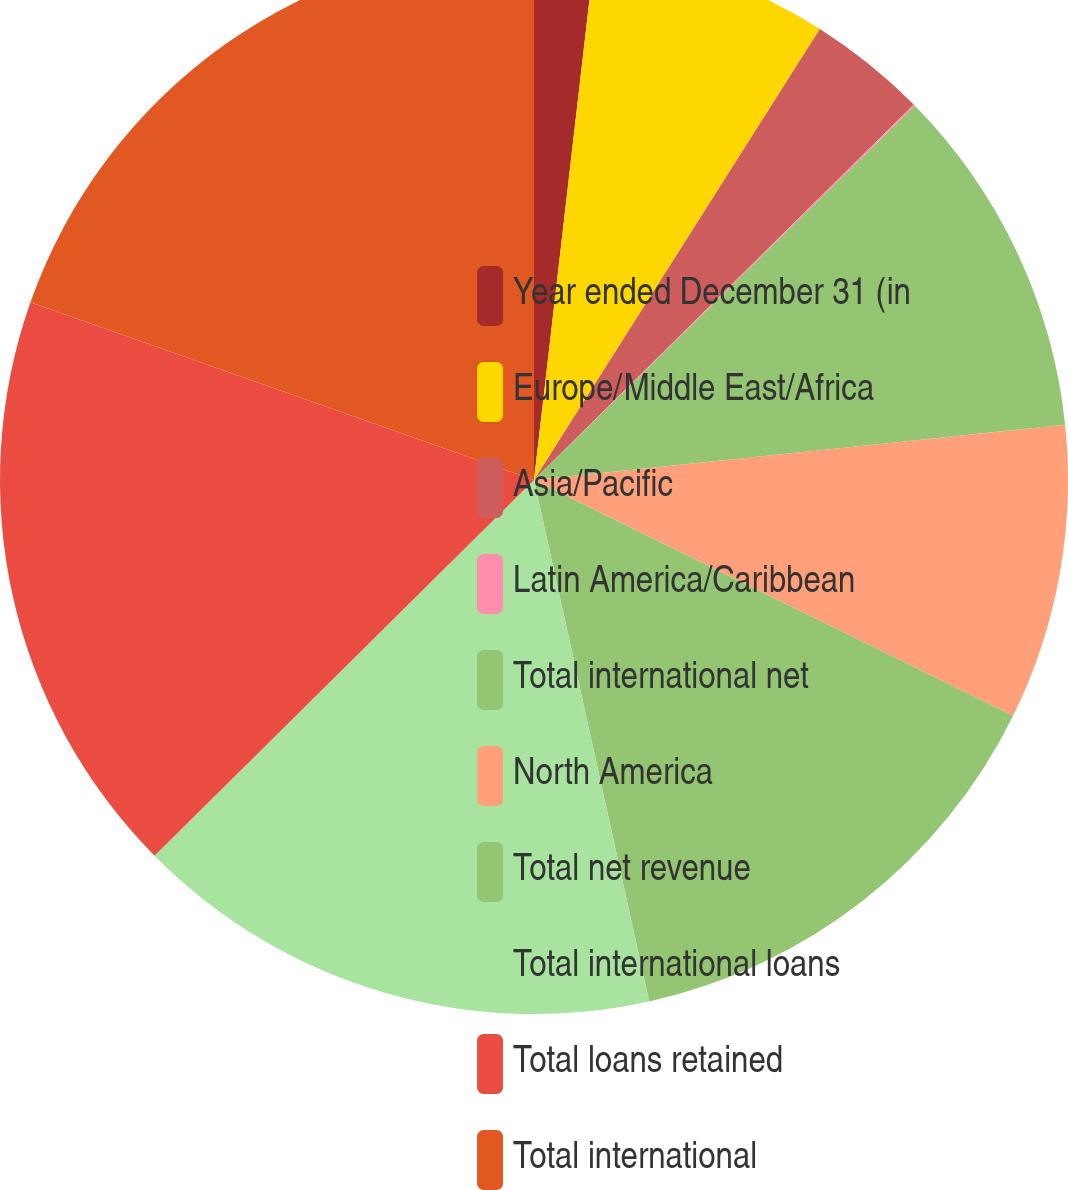Convert chart to OTSL. <chart><loc_0><loc_0><loc_500><loc_500><pie_chart><fcel>Year ended December 31 (in<fcel>Europe/Middle East/Africa<fcel>Asia/Pacific<fcel>Latin America/Caribbean<fcel>Total international net<fcel>North America<fcel>Total net revenue<fcel>Total international loans<fcel>Total loans retained<fcel>Total international<nl><fcel>1.83%<fcel>7.16%<fcel>3.6%<fcel>0.05%<fcel>10.71%<fcel>8.93%<fcel>14.26%<fcel>16.04%<fcel>17.82%<fcel>19.6%<nl></chart> 